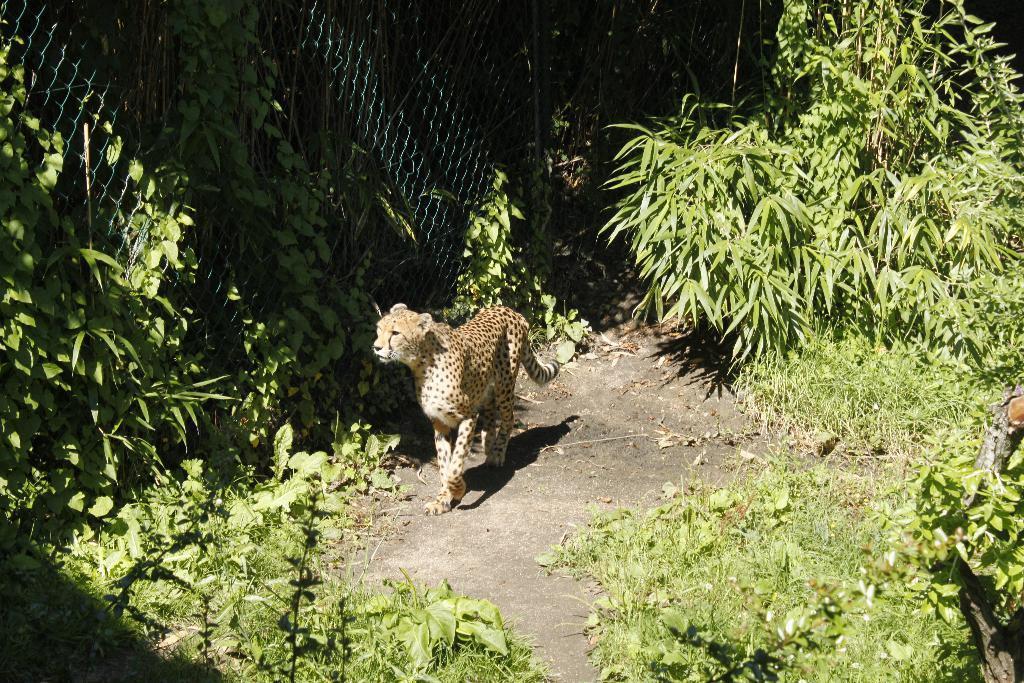Can you describe this image briefly? In this image there is an animal walking on the land having plants. Left side there is a fence having creeper plants. 